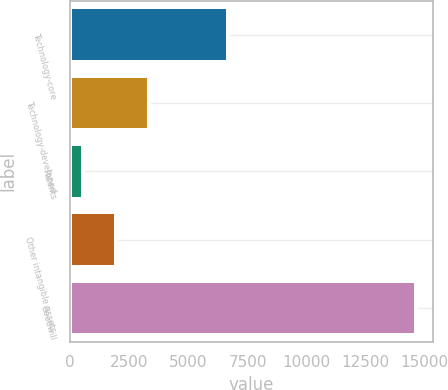Convert chart. <chart><loc_0><loc_0><loc_500><loc_500><bar_chart><fcel>Technology-core<fcel>Technology-developed<fcel>Patents<fcel>Other intangible assets<fcel>Goodwill<nl><fcel>6658<fcel>3344.8<fcel>527<fcel>1935.9<fcel>14616<nl></chart> 